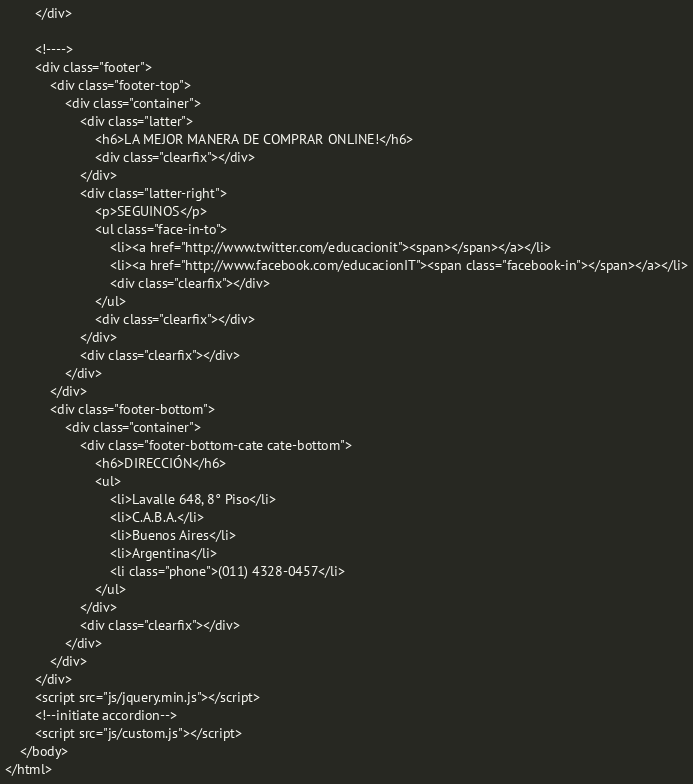Convert code to text. <code><loc_0><loc_0><loc_500><loc_500><_PHP_>		</div>

		<!---->
		<div class="footer">
			<div class="footer-top">
				<div class="container">
					<div class="latter">
						<h6>LA MEJOR MANERA DE COMPRAR ONLINE!</h6>
						<div class="clearfix"></div>
					</div>
					<div class="latter-right">
						<p>SEGUINOS</p>
						<ul class="face-in-to">
							<li><a href="http://www.twitter.com/educacionit"><span></span></a></li>
							<li><a href="http://www.facebook.com/educacionIT"><span class="facebook-in"></span></a></li>
							<div class="clearfix"></div>
						</ul>
						<div class="clearfix"></div>
					</div>
					<div class="clearfix"></div>
				</div>
			</div>
			<div class="footer-bottom">
				<div class="container">
					<div class="footer-bottom-cate cate-bottom">
						<h6>DIRECCIÓN</h6>
						<ul>
							<li>Lavalle 648, 8° Piso</li>
							<li>C.A.B.A.</li>
							<li>Buenos Aires</li>
							<li>Argentina</li>
							<li class="phone">(011) 4328-0457</li>
						</ul>
					</div>
					<div class="clearfix"></div>
				</div>
			</div>
		</div>
		<script src="js/jquery.min.js"></script>
		<!--initiate accordion-->
		<script src="js/custom.js"></script>
	</body>
</html></code> 